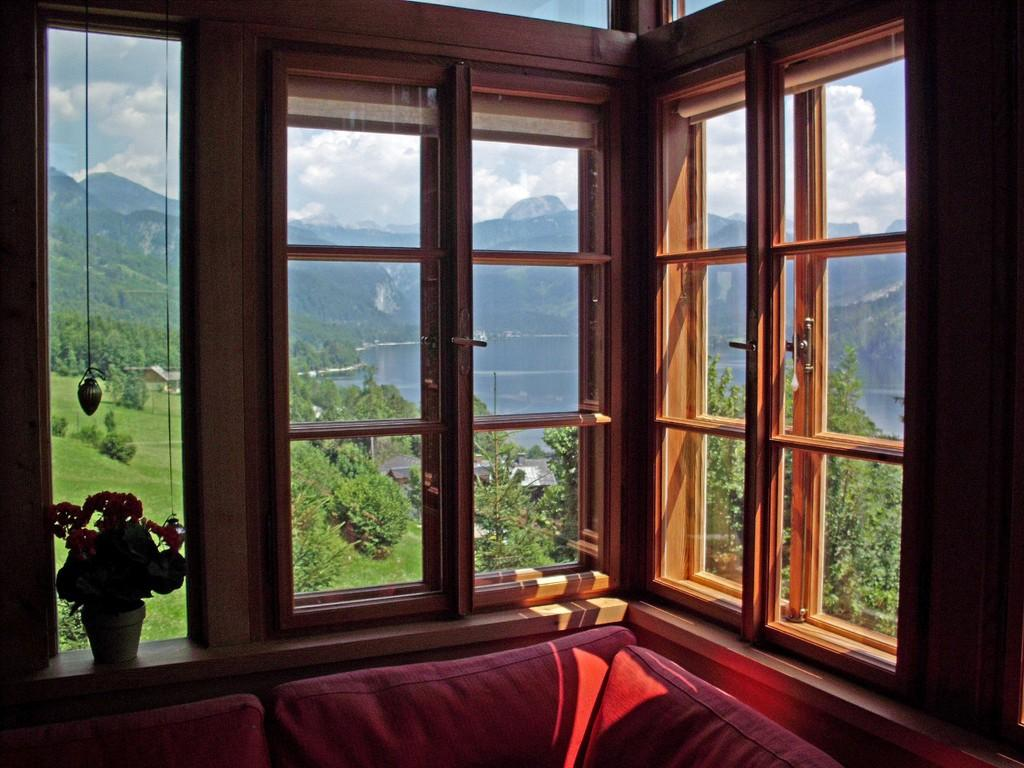What type of windows are visible in the image? There are glass windows in the image. What type of furniture is present in the image? There is a red couch in the image. What type of container is visible in the image? There is a flower pot in the image. What type of natural scenery can be seen in the background of the image? Trees, water, and mountains are visible in the background of the image. What is the color of the sky in the image? The sky is blue and white in color. What type of seat is visible on the ship in the image? There is no ship present in the image, so there are no seats on a ship to be observed. What type of belief is represented by the flower pot in the image? The flower pot does not represent any belief; it is simply a container for plants. 